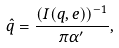<formula> <loc_0><loc_0><loc_500><loc_500>\hat { q } = \frac { ( I ( q , e ) ) ^ { - 1 } } { \pi \alpha ^ { \prime } } ,</formula> 